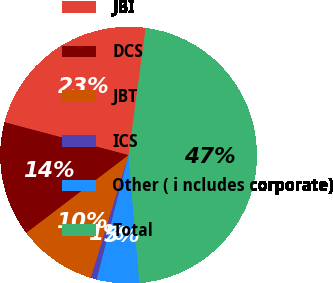Convert chart to OTSL. <chart><loc_0><loc_0><loc_500><loc_500><pie_chart><fcel>JBI<fcel>DCS<fcel>JBT<fcel>ICS<fcel>Other ( i ncludes corporate)<fcel>Total<nl><fcel>23.0%<fcel>14.48%<fcel>9.91%<fcel>0.75%<fcel>5.33%<fcel>46.53%<nl></chart> 